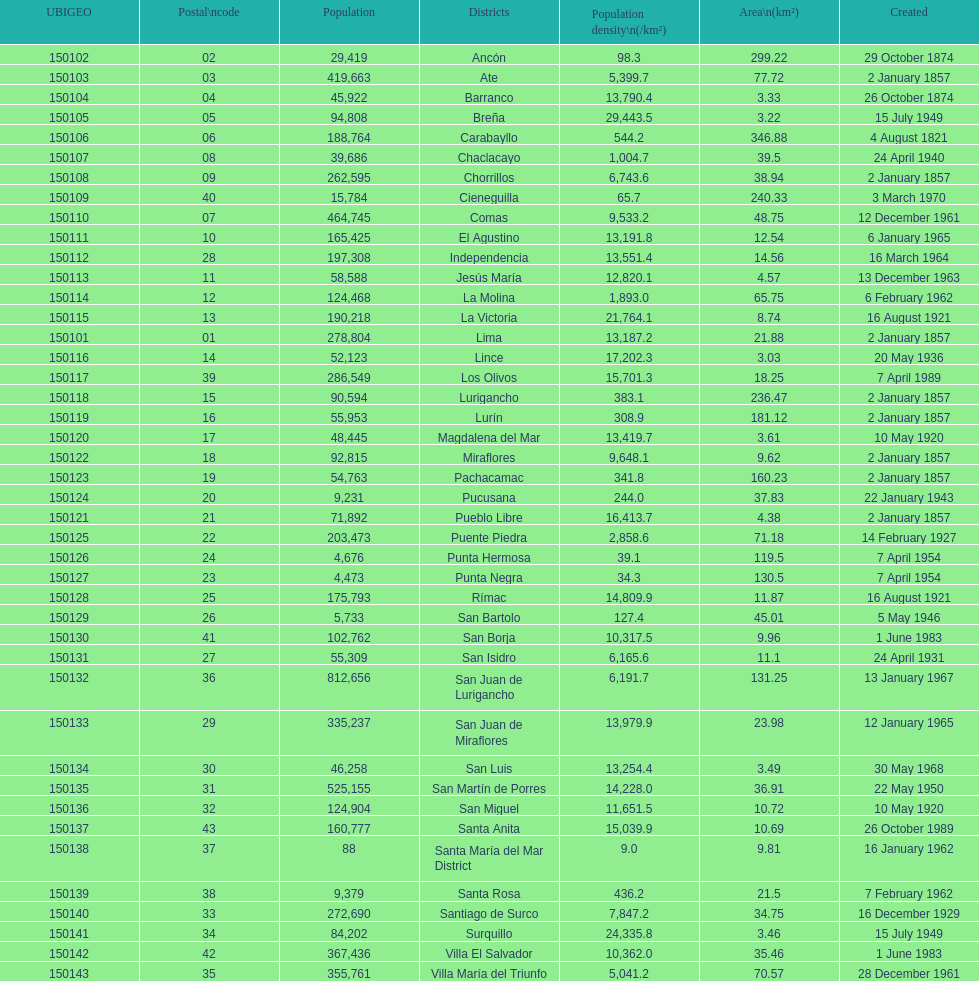How many districts are there in this city? 43. 